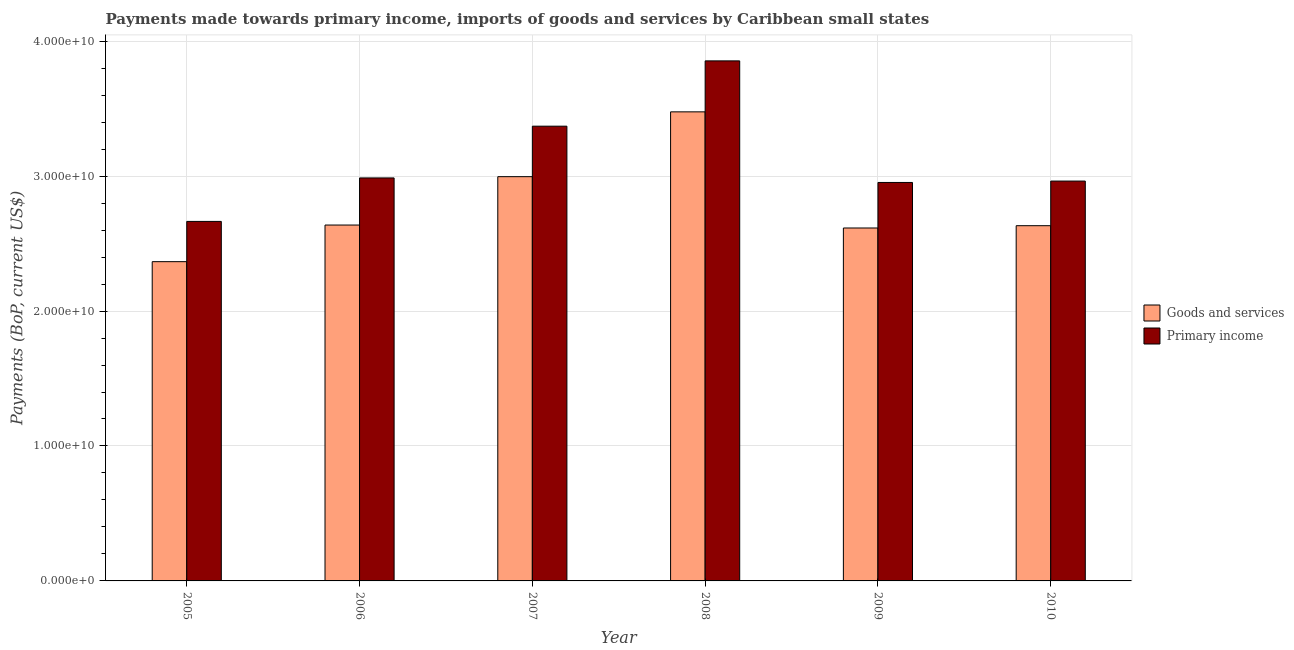How many groups of bars are there?
Your answer should be very brief. 6. Are the number of bars per tick equal to the number of legend labels?
Your answer should be compact. Yes. What is the payments made towards primary income in 2007?
Offer a terse response. 3.37e+1. Across all years, what is the maximum payments made towards goods and services?
Your response must be concise. 3.48e+1. Across all years, what is the minimum payments made towards primary income?
Provide a short and direct response. 2.66e+1. In which year was the payments made towards goods and services minimum?
Ensure brevity in your answer.  2005. What is the total payments made towards goods and services in the graph?
Your answer should be compact. 1.67e+11. What is the difference between the payments made towards primary income in 2007 and that in 2010?
Your answer should be compact. 4.07e+09. What is the difference between the payments made towards primary income in 2005 and the payments made towards goods and services in 2009?
Offer a very short reply. -2.89e+09. What is the average payments made towards primary income per year?
Provide a succinct answer. 3.13e+1. In the year 2010, what is the difference between the payments made towards goods and services and payments made towards primary income?
Your answer should be very brief. 0. What is the ratio of the payments made towards goods and services in 2007 to that in 2008?
Your response must be concise. 0.86. What is the difference between the highest and the second highest payments made towards primary income?
Your response must be concise. 4.84e+09. What is the difference between the highest and the lowest payments made towards goods and services?
Keep it short and to the point. 1.11e+1. In how many years, is the payments made towards primary income greater than the average payments made towards primary income taken over all years?
Provide a succinct answer. 2. Is the sum of the payments made towards primary income in 2007 and 2009 greater than the maximum payments made towards goods and services across all years?
Give a very brief answer. Yes. What does the 1st bar from the left in 2006 represents?
Keep it short and to the point. Goods and services. What does the 2nd bar from the right in 2008 represents?
Offer a terse response. Goods and services. How many bars are there?
Your answer should be compact. 12. Are all the bars in the graph horizontal?
Offer a terse response. No. How many years are there in the graph?
Give a very brief answer. 6. What is the difference between two consecutive major ticks on the Y-axis?
Offer a very short reply. 1.00e+1. Are the values on the major ticks of Y-axis written in scientific E-notation?
Your answer should be compact. Yes. Where does the legend appear in the graph?
Give a very brief answer. Center right. How many legend labels are there?
Offer a terse response. 2. How are the legend labels stacked?
Offer a terse response. Vertical. What is the title of the graph?
Keep it short and to the point. Payments made towards primary income, imports of goods and services by Caribbean small states. What is the label or title of the X-axis?
Offer a very short reply. Year. What is the label or title of the Y-axis?
Provide a short and direct response. Payments (BoP, current US$). What is the Payments (BoP, current US$) in Goods and services in 2005?
Offer a terse response. 2.37e+1. What is the Payments (BoP, current US$) in Primary income in 2005?
Your response must be concise. 2.66e+1. What is the Payments (BoP, current US$) of Goods and services in 2006?
Keep it short and to the point. 2.64e+1. What is the Payments (BoP, current US$) in Primary income in 2006?
Offer a terse response. 2.99e+1. What is the Payments (BoP, current US$) in Goods and services in 2007?
Ensure brevity in your answer.  3.00e+1. What is the Payments (BoP, current US$) of Primary income in 2007?
Offer a very short reply. 3.37e+1. What is the Payments (BoP, current US$) of Goods and services in 2008?
Make the answer very short. 3.48e+1. What is the Payments (BoP, current US$) of Primary income in 2008?
Keep it short and to the point. 3.85e+1. What is the Payments (BoP, current US$) of Goods and services in 2009?
Ensure brevity in your answer.  2.62e+1. What is the Payments (BoP, current US$) of Primary income in 2009?
Provide a succinct answer. 2.95e+1. What is the Payments (BoP, current US$) in Goods and services in 2010?
Keep it short and to the point. 2.63e+1. What is the Payments (BoP, current US$) of Primary income in 2010?
Your answer should be compact. 2.96e+1. Across all years, what is the maximum Payments (BoP, current US$) in Goods and services?
Keep it short and to the point. 3.48e+1. Across all years, what is the maximum Payments (BoP, current US$) in Primary income?
Provide a short and direct response. 3.85e+1. Across all years, what is the minimum Payments (BoP, current US$) in Goods and services?
Your answer should be compact. 2.37e+1. Across all years, what is the minimum Payments (BoP, current US$) in Primary income?
Offer a very short reply. 2.66e+1. What is the total Payments (BoP, current US$) in Goods and services in the graph?
Make the answer very short. 1.67e+11. What is the total Payments (BoP, current US$) in Primary income in the graph?
Your answer should be compact. 1.88e+11. What is the difference between the Payments (BoP, current US$) of Goods and services in 2005 and that in 2006?
Your response must be concise. -2.71e+09. What is the difference between the Payments (BoP, current US$) in Primary income in 2005 and that in 2006?
Your response must be concise. -3.22e+09. What is the difference between the Payments (BoP, current US$) in Goods and services in 2005 and that in 2007?
Ensure brevity in your answer.  -6.30e+09. What is the difference between the Payments (BoP, current US$) of Primary income in 2005 and that in 2007?
Provide a succinct answer. -7.06e+09. What is the difference between the Payments (BoP, current US$) of Goods and services in 2005 and that in 2008?
Your answer should be very brief. -1.11e+1. What is the difference between the Payments (BoP, current US$) in Primary income in 2005 and that in 2008?
Your answer should be compact. -1.19e+1. What is the difference between the Payments (BoP, current US$) of Goods and services in 2005 and that in 2009?
Your answer should be compact. -2.49e+09. What is the difference between the Payments (BoP, current US$) of Primary income in 2005 and that in 2009?
Your response must be concise. -2.89e+09. What is the difference between the Payments (BoP, current US$) in Goods and services in 2005 and that in 2010?
Make the answer very short. -2.66e+09. What is the difference between the Payments (BoP, current US$) in Primary income in 2005 and that in 2010?
Your answer should be compact. -2.99e+09. What is the difference between the Payments (BoP, current US$) of Goods and services in 2006 and that in 2007?
Provide a short and direct response. -3.59e+09. What is the difference between the Payments (BoP, current US$) of Primary income in 2006 and that in 2007?
Provide a succinct answer. -3.84e+09. What is the difference between the Payments (BoP, current US$) in Goods and services in 2006 and that in 2008?
Your answer should be compact. -8.39e+09. What is the difference between the Payments (BoP, current US$) in Primary income in 2006 and that in 2008?
Your answer should be compact. -8.67e+09. What is the difference between the Payments (BoP, current US$) of Goods and services in 2006 and that in 2009?
Your answer should be compact. 2.18e+08. What is the difference between the Payments (BoP, current US$) in Primary income in 2006 and that in 2009?
Provide a short and direct response. 3.36e+08. What is the difference between the Payments (BoP, current US$) in Goods and services in 2006 and that in 2010?
Offer a terse response. 4.84e+07. What is the difference between the Payments (BoP, current US$) of Primary income in 2006 and that in 2010?
Your answer should be very brief. 2.33e+08. What is the difference between the Payments (BoP, current US$) in Goods and services in 2007 and that in 2008?
Your answer should be compact. -4.80e+09. What is the difference between the Payments (BoP, current US$) of Primary income in 2007 and that in 2008?
Offer a very short reply. -4.84e+09. What is the difference between the Payments (BoP, current US$) in Goods and services in 2007 and that in 2009?
Make the answer very short. 3.80e+09. What is the difference between the Payments (BoP, current US$) of Primary income in 2007 and that in 2009?
Keep it short and to the point. 4.17e+09. What is the difference between the Payments (BoP, current US$) of Goods and services in 2007 and that in 2010?
Your answer should be very brief. 3.63e+09. What is the difference between the Payments (BoP, current US$) of Primary income in 2007 and that in 2010?
Offer a very short reply. 4.07e+09. What is the difference between the Payments (BoP, current US$) of Goods and services in 2008 and that in 2009?
Provide a short and direct response. 8.61e+09. What is the difference between the Payments (BoP, current US$) of Primary income in 2008 and that in 2009?
Ensure brevity in your answer.  9.01e+09. What is the difference between the Payments (BoP, current US$) in Goods and services in 2008 and that in 2010?
Give a very brief answer. 8.44e+09. What is the difference between the Payments (BoP, current US$) of Primary income in 2008 and that in 2010?
Provide a succinct answer. 8.91e+09. What is the difference between the Payments (BoP, current US$) of Goods and services in 2009 and that in 2010?
Keep it short and to the point. -1.70e+08. What is the difference between the Payments (BoP, current US$) in Primary income in 2009 and that in 2010?
Your response must be concise. -1.03e+08. What is the difference between the Payments (BoP, current US$) of Goods and services in 2005 and the Payments (BoP, current US$) of Primary income in 2006?
Provide a succinct answer. -6.20e+09. What is the difference between the Payments (BoP, current US$) in Goods and services in 2005 and the Payments (BoP, current US$) in Primary income in 2007?
Your answer should be very brief. -1.00e+1. What is the difference between the Payments (BoP, current US$) of Goods and services in 2005 and the Payments (BoP, current US$) of Primary income in 2008?
Give a very brief answer. -1.49e+1. What is the difference between the Payments (BoP, current US$) of Goods and services in 2005 and the Payments (BoP, current US$) of Primary income in 2009?
Keep it short and to the point. -5.87e+09. What is the difference between the Payments (BoP, current US$) in Goods and services in 2005 and the Payments (BoP, current US$) in Primary income in 2010?
Your answer should be very brief. -5.97e+09. What is the difference between the Payments (BoP, current US$) in Goods and services in 2006 and the Payments (BoP, current US$) in Primary income in 2007?
Give a very brief answer. -7.33e+09. What is the difference between the Payments (BoP, current US$) of Goods and services in 2006 and the Payments (BoP, current US$) of Primary income in 2008?
Make the answer very short. -1.22e+1. What is the difference between the Payments (BoP, current US$) in Goods and services in 2006 and the Payments (BoP, current US$) in Primary income in 2009?
Your answer should be very brief. -3.16e+09. What is the difference between the Payments (BoP, current US$) in Goods and services in 2006 and the Payments (BoP, current US$) in Primary income in 2010?
Make the answer very short. -3.26e+09. What is the difference between the Payments (BoP, current US$) of Goods and services in 2007 and the Payments (BoP, current US$) of Primary income in 2008?
Keep it short and to the point. -8.58e+09. What is the difference between the Payments (BoP, current US$) of Goods and services in 2007 and the Payments (BoP, current US$) of Primary income in 2009?
Make the answer very short. 4.30e+08. What is the difference between the Payments (BoP, current US$) in Goods and services in 2007 and the Payments (BoP, current US$) in Primary income in 2010?
Ensure brevity in your answer.  3.27e+08. What is the difference between the Payments (BoP, current US$) of Goods and services in 2008 and the Payments (BoP, current US$) of Primary income in 2009?
Make the answer very short. 5.23e+09. What is the difference between the Payments (BoP, current US$) in Goods and services in 2008 and the Payments (BoP, current US$) in Primary income in 2010?
Give a very brief answer. 5.13e+09. What is the difference between the Payments (BoP, current US$) in Goods and services in 2009 and the Payments (BoP, current US$) in Primary income in 2010?
Provide a short and direct response. -3.48e+09. What is the average Payments (BoP, current US$) in Goods and services per year?
Make the answer very short. 2.79e+1. What is the average Payments (BoP, current US$) in Primary income per year?
Your response must be concise. 3.13e+1. In the year 2005, what is the difference between the Payments (BoP, current US$) in Goods and services and Payments (BoP, current US$) in Primary income?
Ensure brevity in your answer.  -2.98e+09. In the year 2006, what is the difference between the Payments (BoP, current US$) in Goods and services and Payments (BoP, current US$) in Primary income?
Keep it short and to the point. -3.49e+09. In the year 2007, what is the difference between the Payments (BoP, current US$) of Goods and services and Payments (BoP, current US$) of Primary income?
Keep it short and to the point. -3.74e+09. In the year 2008, what is the difference between the Payments (BoP, current US$) in Goods and services and Payments (BoP, current US$) in Primary income?
Provide a succinct answer. -3.78e+09. In the year 2009, what is the difference between the Payments (BoP, current US$) in Goods and services and Payments (BoP, current US$) in Primary income?
Give a very brief answer. -3.37e+09. In the year 2010, what is the difference between the Payments (BoP, current US$) in Goods and services and Payments (BoP, current US$) in Primary income?
Your answer should be very brief. -3.31e+09. What is the ratio of the Payments (BoP, current US$) in Goods and services in 2005 to that in 2006?
Offer a very short reply. 0.9. What is the ratio of the Payments (BoP, current US$) of Primary income in 2005 to that in 2006?
Provide a short and direct response. 0.89. What is the ratio of the Payments (BoP, current US$) in Goods and services in 2005 to that in 2007?
Your answer should be compact. 0.79. What is the ratio of the Payments (BoP, current US$) in Primary income in 2005 to that in 2007?
Offer a very short reply. 0.79. What is the ratio of the Payments (BoP, current US$) in Goods and services in 2005 to that in 2008?
Your answer should be compact. 0.68. What is the ratio of the Payments (BoP, current US$) of Primary income in 2005 to that in 2008?
Your answer should be compact. 0.69. What is the ratio of the Payments (BoP, current US$) of Goods and services in 2005 to that in 2009?
Your answer should be compact. 0.9. What is the ratio of the Payments (BoP, current US$) of Primary income in 2005 to that in 2009?
Give a very brief answer. 0.9. What is the ratio of the Payments (BoP, current US$) of Goods and services in 2005 to that in 2010?
Your answer should be very brief. 0.9. What is the ratio of the Payments (BoP, current US$) of Primary income in 2005 to that in 2010?
Give a very brief answer. 0.9. What is the ratio of the Payments (BoP, current US$) of Goods and services in 2006 to that in 2007?
Your answer should be very brief. 0.88. What is the ratio of the Payments (BoP, current US$) in Primary income in 2006 to that in 2007?
Offer a terse response. 0.89. What is the ratio of the Payments (BoP, current US$) of Goods and services in 2006 to that in 2008?
Provide a succinct answer. 0.76. What is the ratio of the Payments (BoP, current US$) in Primary income in 2006 to that in 2008?
Keep it short and to the point. 0.77. What is the ratio of the Payments (BoP, current US$) in Goods and services in 2006 to that in 2009?
Give a very brief answer. 1.01. What is the ratio of the Payments (BoP, current US$) of Primary income in 2006 to that in 2009?
Your response must be concise. 1.01. What is the ratio of the Payments (BoP, current US$) in Primary income in 2006 to that in 2010?
Keep it short and to the point. 1.01. What is the ratio of the Payments (BoP, current US$) in Goods and services in 2007 to that in 2008?
Offer a terse response. 0.86. What is the ratio of the Payments (BoP, current US$) of Primary income in 2007 to that in 2008?
Give a very brief answer. 0.87. What is the ratio of the Payments (BoP, current US$) of Goods and services in 2007 to that in 2009?
Your response must be concise. 1.15. What is the ratio of the Payments (BoP, current US$) of Primary income in 2007 to that in 2009?
Offer a very short reply. 1.14. What is the ratio of the Payments (BoP, current US$) in Goods and services in 2007 to that in 2010?
Ensure brevity in your answer.  1.14. What is the ratio of the Payments (BoP, current US$) of Primary income in 2007 to that in 2010?
Give a very brief answer. 1.14. What is the ratio of the Payments (BoP, current US$) of Goods and services in 2008 to that in 2009?
Offer a terse response. 1.33. What is the ratio of the Payments (BoP, current US$) of Primary income in 2008 to that in 2009?
Your answer should be very brief. 1.31. What is the ratio of the Payments (BoP, current US$) of Goods and services in 2008 to that in 2010?
Offer a terse response. 1.32. What is the ratio of the Payments (BoP, current US$) in Primary income in 2008 to that in 2010?
Provide a short and direct response. 1.3. What is the ratio of the Payments (BoP, current US$) of Primary income in 2009 to that in 2010?
Provide a succinct answer. 1. What is the difference between the highest and the second highest Payments (BoP, current US$) of Goods and services?
Your answer should be compact. 4.80e+09. What is the difference between the highest and the second highest Payments (BoP, current US$) in Primary income?
Give a very brief answer. 4.84e+09. What is the difference between the highest and the lowest Payments (BoP, current US$) of Goods and services?
Your answer should be compact. 1.11e+1. What is the difference between the highest and the lowest Payments (BoP, current US$) in Primary income?
Make the answer very short. 1.19e+1. 